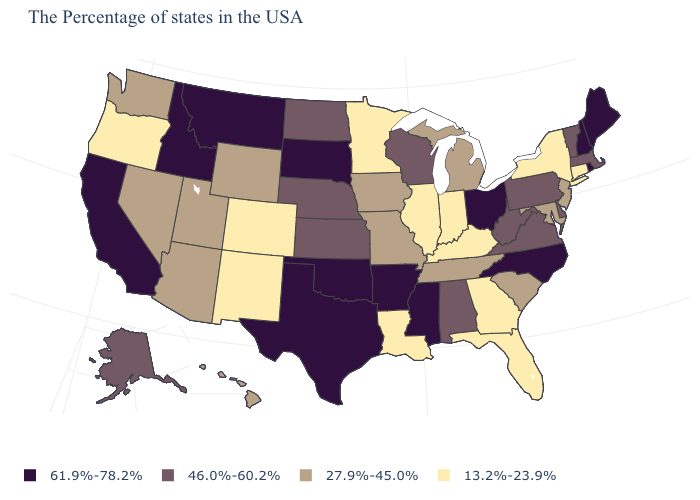Does the first symbol in the legend represent the smallest category?
Short answer required. No. Is the legend a continuous bar?
Write a very short answer. No. Name the states that have a value in the range 27.9%-45.0%?
Keep it brief. New Jersey, Maryland, South Carolina, Michigan, Tennessee, Missouri, Iowa, Wyoming, Utah, Arizona, Nevada, Washington, Hawaii. Which states hav the highest value in the West?
Give a very brief answer. Montana, Idaho, California. Name the states that have a value in the range 13.2%-23.9%?
Quick response, please. Connecticut, New York, Florida, Georgia, Kentucky, Indiana, Illinois, Louisiana, Minnesota, Colorado, New Mexico, Oregon. Does Alabama have the highest value in the South?
Be succinct. No. Does Nebraska have the lowest value in the MidWest?
Concise answer only. No. What is the value of Alabama?
Write a very short answer. 46.0%-60.2%. Name the states that have a value in the range 46.0%-60.2%?
Answer briefly. Massachusetts, Vermont, Delaware, Pennsylvania, Virginia, West Virginia, Alabama, Wisconsin, Kansas, Nebraska, North Dakota, Alaska. Name the states that have a value in the range 61.9%-78.2%?
Give a very brief answer. Maine, Rhode Island, New Hampshire, North Carolina, Ohio, Mississippi, Arkansas, Oklahoma, Texas, South Dakota, Montana, Idaho, California. What is the highest value in the USA?
Keep it brief. 61.9%-78.2%. Name the states that have a value in the range 27.9%-45.0%?
Concise answer only. New Jersey, Maryland, South Carolina, Michigan, Tennessee, Missouri, Iowa, Wyoming, Utah, Arizona, Nevada, Washington, Hawaii. Name the states that have a value in the range 13.2%-23.9%?
Keep it brief. Connecticut, New York, Florida, Georgia, Kentucky, Indiana, Illinois, Louisiana, Minnesota, Colorado, New Mexico, Oregon. Among the states that border Wisconsin , does Minnesota have the lowest value?
Be succinct. Yes. Is the legend a continuous bar?
Keep it brief. No. 